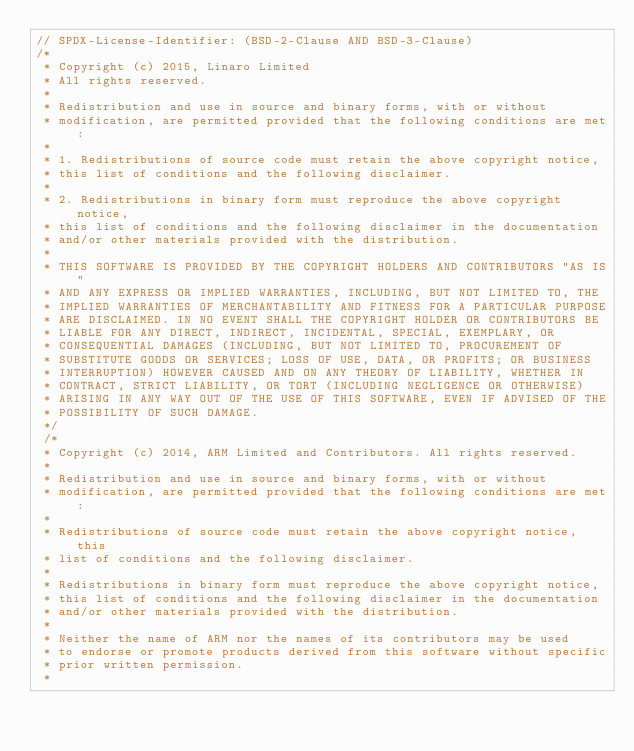Convert code to text. <code><loc_0><loc_0><loc_500><loc_500><_C_>// SPDX-License-Identifier: (BSD-2-Clause AND BSD-3-Clause)
/*
 * Copyright (c) 2015, Linaro Limited
 * All rights reserved.
 *
 * Redistribution and use in source and binary forms, with or without
 * modification, are permitted provided that the following conditions are met:
 *
 * 1. Redistributions of source code must retain the above copyright notice,
 * this list of conditions and the following disclaimer.
 *
 * 2. Redistributions in binary form must reproduce the above copyright notice,
 * this list of conditions and the following disclaimer in the documentation
 * and/or other materials provided with the distribution.
 *
 * THIS SOFTWARE IS PROVIDED BY THE COPYRIGHT HOLDERS AND CONTRIBUTORS "AS IS"
 * AND ANY EXPRESS OR IMPLIED WARRANTIES, INCLUDING, BUT NOT LIMITED TO, THE
 * IMPLIED WARRANTIES OF MERCHANTABILITY AND FITNESS FOR A PARTICULAR PURPOSE
 * ARE DISCLAIMED. IN NO EVENT SHALL THE COPYRIGHT HOLDER OR CONTRIBUTORS BE
 * LIABLE FOR ANY DIRECT, INDIRECT, INCIDENTAL, SPECIAL, EXEMPLARY, OR
 * CONSEQUENTIAL DAMAGES (INCLUDING, BUT NOT LIMITED TO, PROCUREMENT OF
 * SUBSTITUTE GOODS OR SERVICES; LOSS OF USE, DATA, OR PROFITS; OR BUSINESS
 * INTERRUPTION) HOWEVER CAUSED AND ON ANY THEORY OF LIABILITY, WHETHER IN
 * CONTRACT, STRICT LIABILITY, OR TORT (INCLUDING NEGLIGENCE OR OTHERWISE)
 * ARISING IN ANY WAY OUT OF THE USE OF THIS SOFTWARE, EVEN IF ADVISED OF THE
 * POSSIBILITY OF SUCH DAMAGE.
 */
 /*
 * Copyright (c) 2014, ARM Limited and Contributors. All rights reserved.
 *
 * Redistribution and use in source and binary forms, with or without
 * modification, are permitted provided that the following conditions are met:
 *
 * Redistributions of source code must retain the above copyright notice, this
 * list of conditions and the following disclaimer.
 *
 * Redistributions in binary form must reproduce the above copyright notice,
 * this list of conditions and the following disclaimer in the documentation
 * and/or other materials provided with the distribution.
 *
 * Neither the name of ARM nor the names of its contributors may be used
 * to endorse or promote products derived from this software without specific
 * prior written permission.
 *</code> 